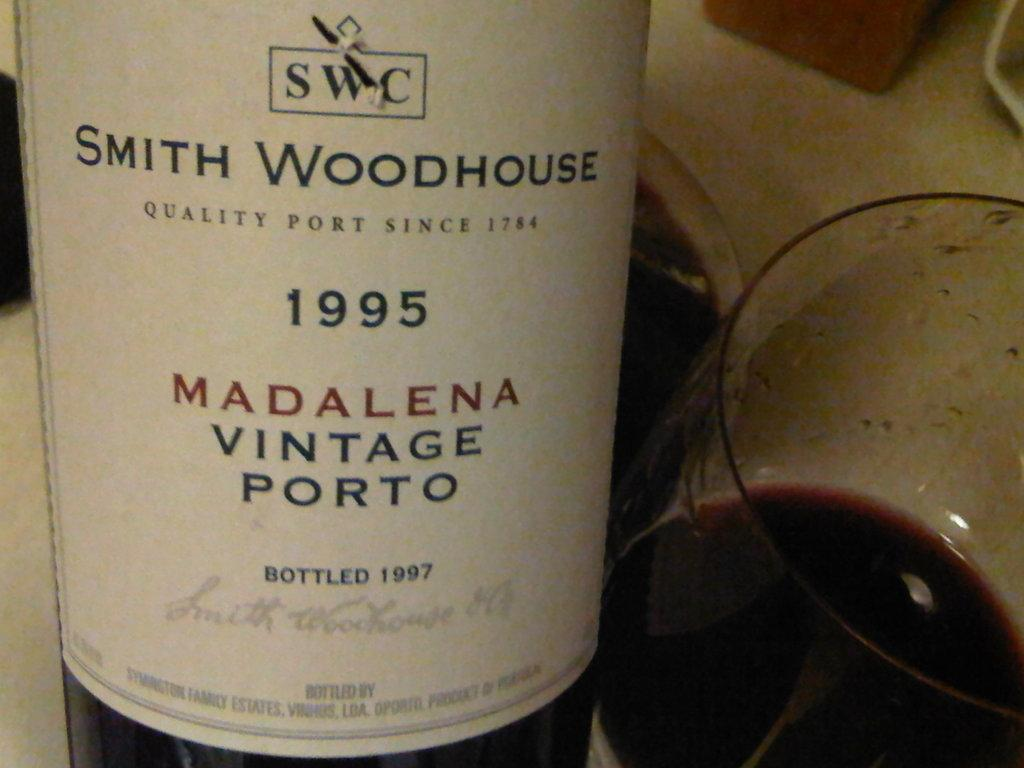<image>
Summarize the visual content of the image. A glass of wine alongside the bottle of Smith Woodhouse Madalena Vintage Porto, from 1995. 